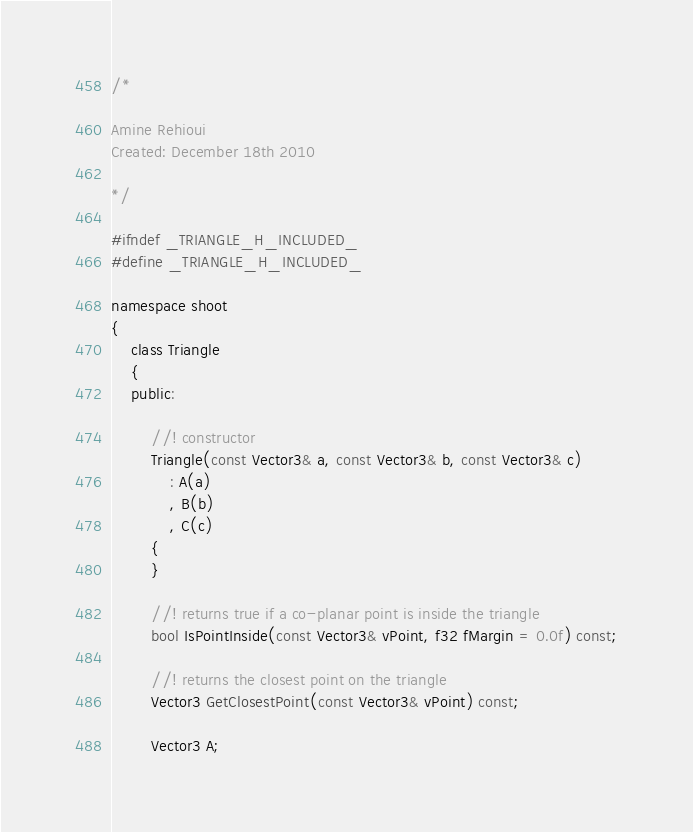<code> <loc_0><loc_0><loc_500><loc_500><_C_>/* 

Amine Rehioui
Created: December 18th 2010

*/

#ifndef _TRIANGLE_H_INCLUDED_
#define _TRIANGLE_H_INCLUDED_

namespace shoot
{
	class Triangle
	{
	public:

		//! constructor
		Triangle(const Vector3& a, const Vector3& b, const Vector3& c)
			: A(a)
			, B(b)
			, C(c)
		{
		}

		//! returns true if a co-planar point is inside the triangle
		bool IsPointInside(const Vector3& vPoint, f32 fMargin = 0.0f) const;

		//! returns the closest point on the triangle
		Vector3 GetClosestPoint(const Vector3& vPoint) const;

		Vector3 A;</code> 